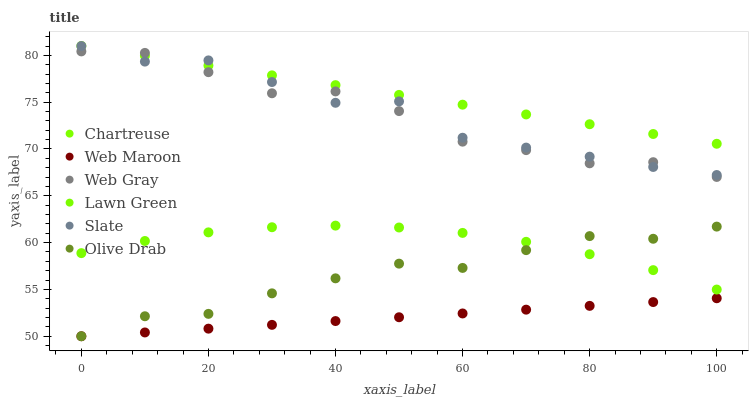Does Web Maroon have the minimum area under the curve?
Answer yes or no. Yes. Does Chartreuse have the maximum area under the curve?
Answer yes or no. Yes. Does Web Gray have the minimum area under the curve?
Answer yes or no. No. Does Web Gray have the maximum area under the curve?
Answer yes or no. No. Is Web Maroon the smoothest?
Answer yes or no. Yes. Is Web Gray the roughest?
Answer yes or no. Yes. Is Slate the smoothest?
Answer yes or no. No. Is Slate the roughest?
Answer yes or no. No. Does Web Maroon have the lowest value?
Answer yes or no. Yes. Does Web Gray have the lowest value?
Answer yes or no. No. Does Chartreuse have the highest value?
Answer yes or no. Yes. Does Web Gray have the highest value?
Answer yes or no. No. Is Web Maroon less than Chartreuse?
Answer yes or no. Yes. Is Web Gray greater than Lawn Green?
Answer yes or no. Yes. Does Web Gray intersect Slate?
Answer yes or no. Yes. Is Web Gray less than Slate?
Answer yes or no. No. Is Web Gray greater than Slate?
Answer yes or no. No. Does Web Maroon intersect Chartreuse?
Answer yes or no. No. 